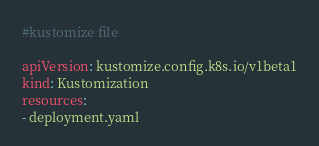<code> <loc_0><loc_0><loc_500><loc_500><_YAML_>#kustomize file 

apiVersion: kustomize.config.k8s.io/v1beta1
kind: Kustomization
resources:
- deployment.yaml
</code> 